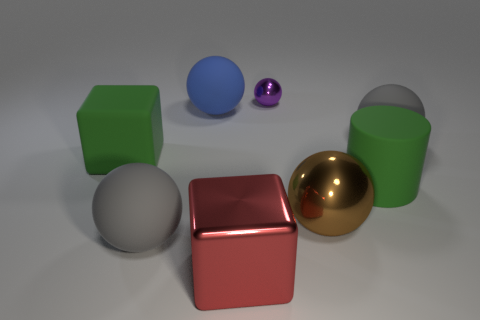Is there anything else that is the same size as the purple metallic object?
Provide a succinct answer. No. Are there fewer tiny metal spheres than large cyan metallic objects?
Give a very brief answer. No. Are the green thing that is on the left side of the big blue sphere and the small purple ball made of the same material?
Provide a short and direct response. No. What number of balls are either large things or big shiny objects?
Offer a terse response. 4. What is the shape of the rubber object that is both on the left side of the large cylinder and in front of the green rubber block?
Your answer should be compact. Sphere. There is a cube behind the cube right of the big block behind the big cylinder; what color is it?
Offer a very short reply. Green. Is the number of large green matte blocks in front of the tiny shiny object less than the number of big gray rubber things?
Offer a very short reply. Yes. Is the shape of the large green rubber object on the right side of the metal block the same as the big rubber object that is in front of the brown thing?
Your response must be concise. No. How many objects are big red metal things that are to the right of the large blue matte object or large brown metallic objects?
Your answer should be compact. 2. There is a large gray rubber sphere on the left side of the large gray thing that is right of the small object; is there a green matte object to the right of it?
Your answer should be very brief. Yes. 